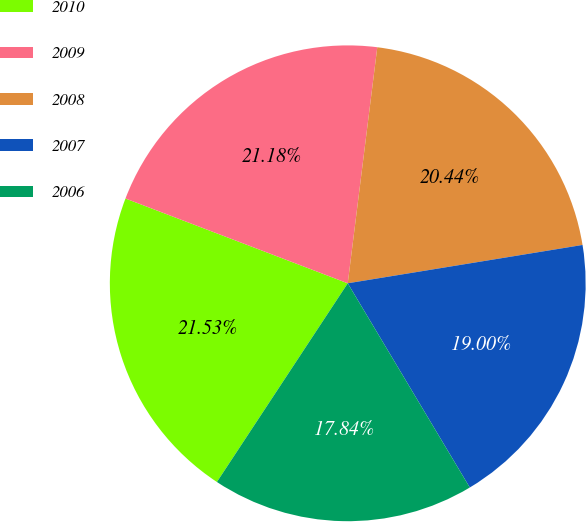Convert chart to OTSL. <chart><loc_0><loc_0><loc_500><loc_500><pie_chart><fcel>2010<fcel>2009<fcel>2008<fcel>2007<fcel>2006<nl><fcel>21.53%<fcel>21.18%<fcel>20.44%<fcel>19.0%<fcel>17.84%<nl></chart> 